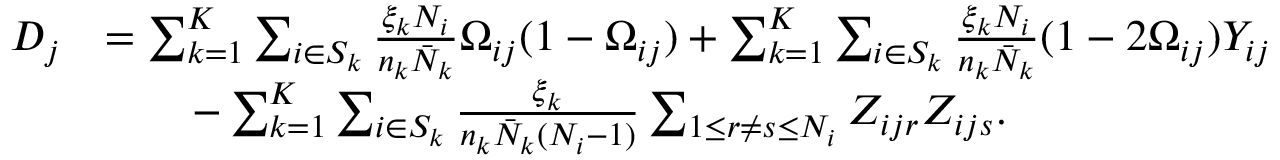Convert formula to latex. <formula><loc_0><loc_0><loc_500><loc_500>\begin{array} { r l } { D _ { j } } & { = \sum _ { k = 1 } ^ { K } \sum _ { i \in S _ { k } } \frac { \xi _ { k } N _ { i } } { n _ { k } \bar { N } _ { k } } \Omega _ { i j } ( 1 - \Omega _ { i j } ) + \sum _ { k = 1 } ^ { K } \sum _ { i \in S _ { k } } \frac { \xi _ { k } N _ { i } } { n _ { k } \bar { N } _ { k } } ( 1 - 2 \Omega _ { i j } ) Y _ { i j } } \\ & { \quad - \sum _ { k = 1 } ^ { K } \sum _ { i \in S _ { k } } \frac { \xi _ { k } } { n _ { k } \bar { N } _ { k } ( N _ { i } - 1 ) } \sum _ { 1 \leq r \neq s \leq N _ { i } } Z _ { i j r } Z _ { i j s } . } \end{array}</formula> 